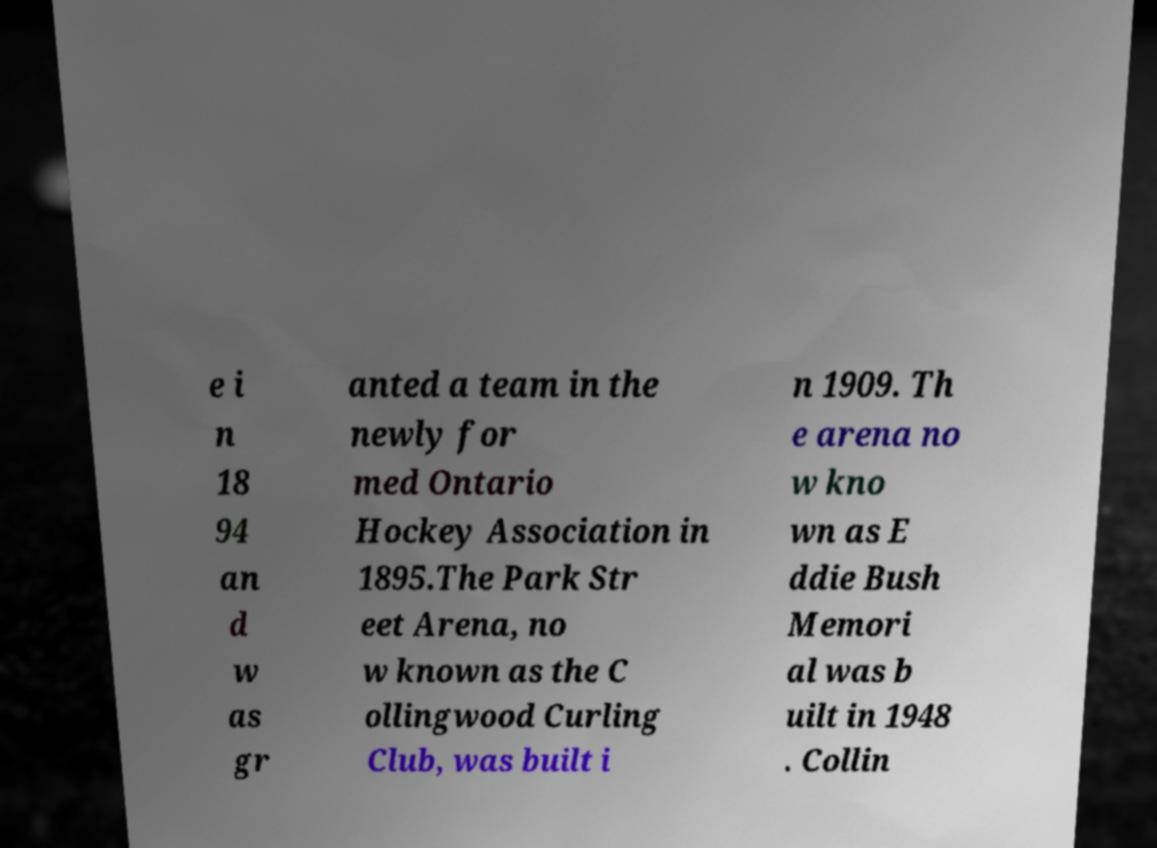I need the written content from this picture converted into text. Can you do that? e i n 18 94 an d w as gr anted a team in the newly for med Ontario Hockey Association in 1895.The Park Str eet Arena, no w known as the C ollingwood Curling Club, was built i n 1909. Th e arena no w kno wn as E ddie Bush Memori al was b uilt in 1948 . Collin 